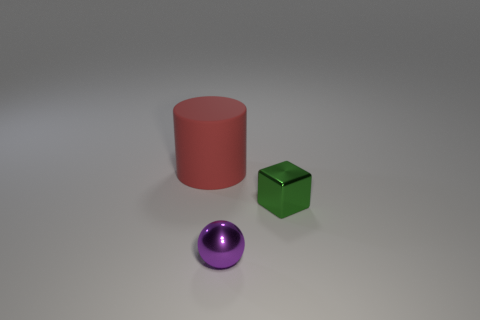Add 1 tiny blue metal things. How many objects exist? 4 Subtract all cylinders. How many objects are left? 2 Add 1 green blocks. How many green blocks exist? 2 Subtract 0 blue spheres. How many objects are left? 3 Subtract all large blue balls. Subtract all red cylinders. How many objects are left? 2 Add 1 big rubber objects. How many big rubber objects are left? 2 